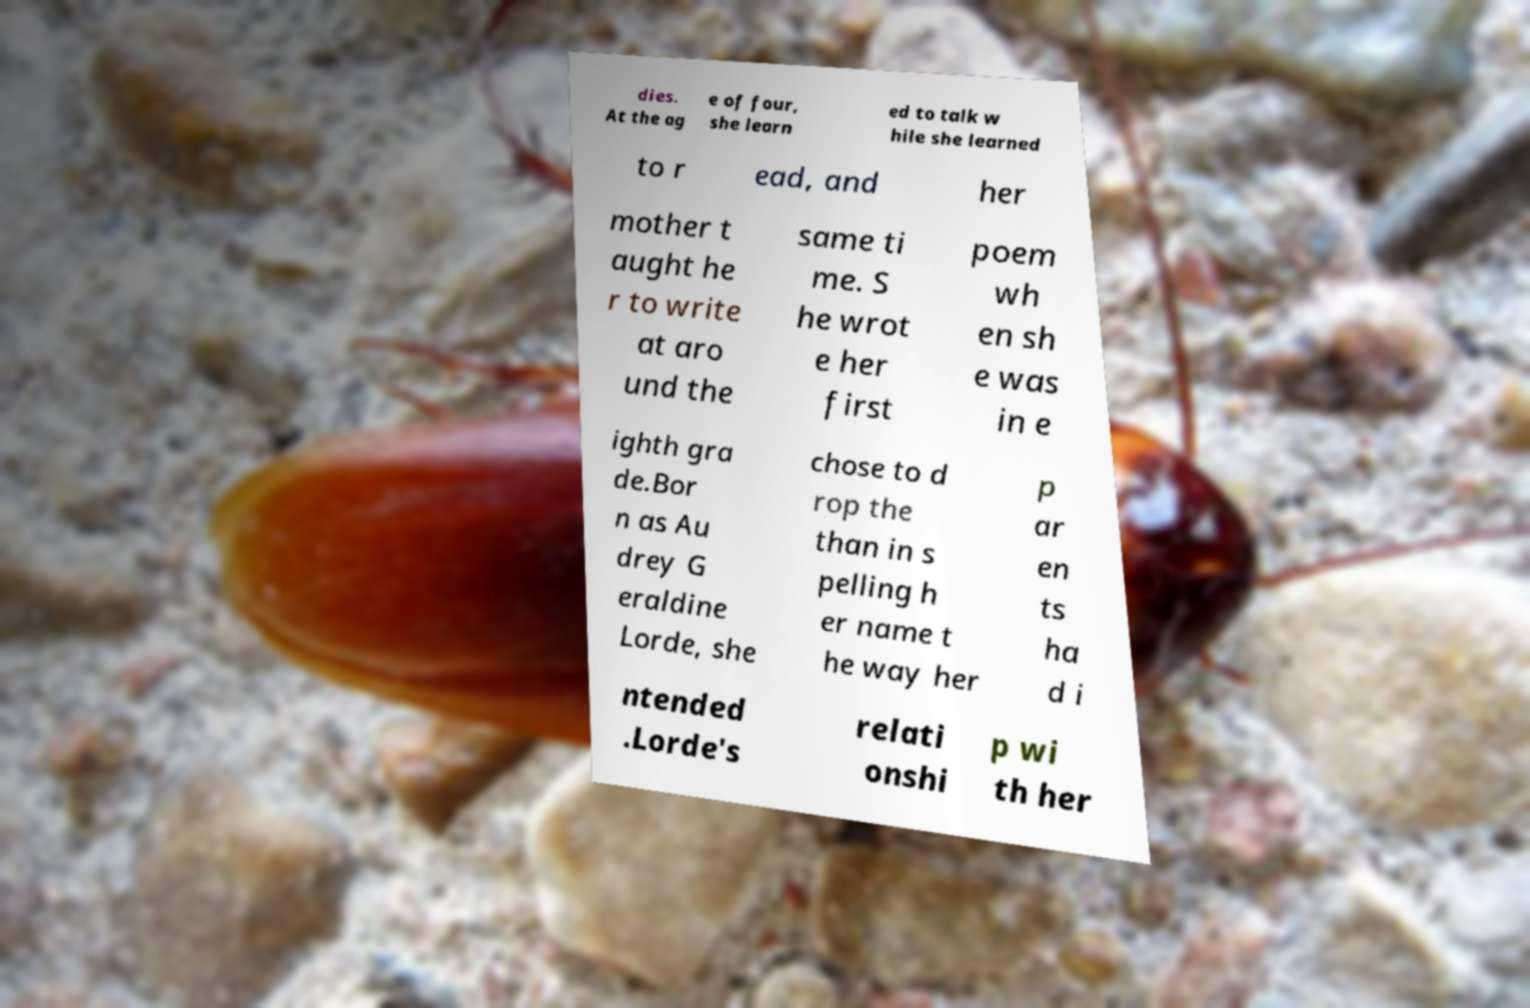Can you accurately transcribe the text from the provided image for me? dies. At the ag e of four, she learn ed to talk w hile she learned to r ead, and her mother t aught he r to write at aro und the same ti me. S he wrot e her first poem wh en sh e was in e ighth gra de.Bor n as Au drey G eraldine Lorde, she chose to d rop the than in s pelling h er name t he way her p ar en ts ha d i ntended .Lorde's relati onshi p wi th her 